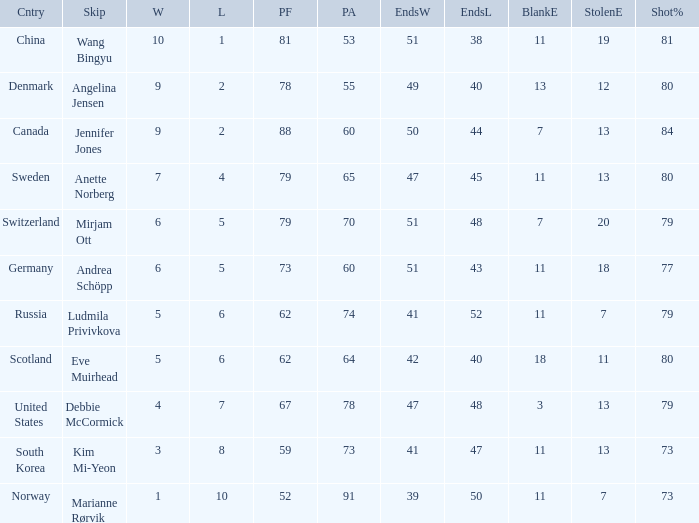Andrea Schöpp is the skip of which country? Germany. 